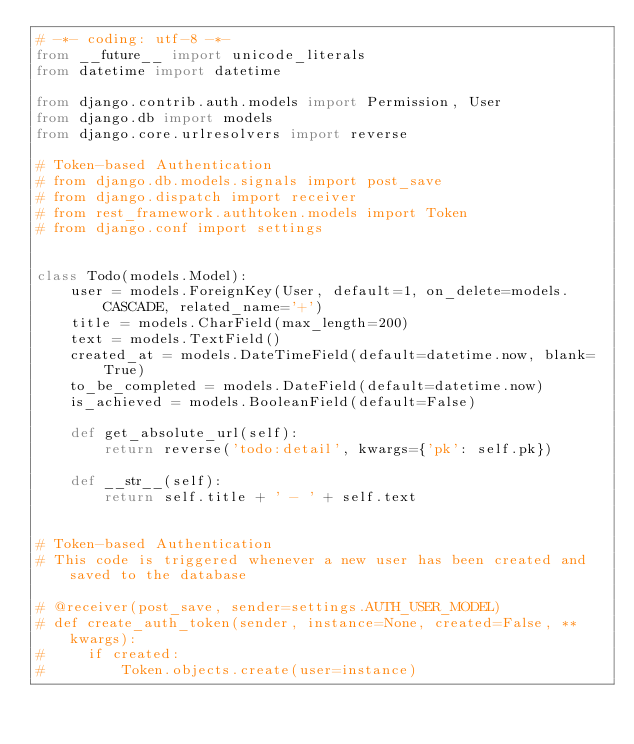<code> <loc_0><loc_0><loc_500><loc_500><_Python_># -*- coding: utf-8 -*-
from __future__ import unicode_literals
from datetime import datetime

from django.contrib.auth.models import Permission, User
from django.db import models
from django.core.urlresolvers import reverse

# Token-based Authentication
# from django.db.models.signals import post_save
# from django.dispatch import receiver
# from rest_framework.authtoken.models import Token
# from django.conf import settings


class Todo(models.Model):
    user = models.ForeignKey(User, default=1, on_delete=models.CASCADE, related_name='+')
    title = models.CharField(max_length=200)
    text = models.TextField()
    created_at = models.DateTimeField(default=datetime.now, blank=True)
    to_be_completed = models.DateField(default=datetime.now)
    is_achieved = models.BooleanField(default=False)

    def get_absolute_url(self):
        return reverse('todo:detail', kwargs={'pk': self.pk})

    def __str__(self):
        return self.title + ' - ' + self.text


# Token-based Authentication
# This code is triggered whenever a new user has been created and saved to the database

# @receiver(post_save, sender=settings.AUTH_USER_MODEL)
# def create_auth_token(sender, instance=None, created=False, **kwargs):
#     if created:
#         Token.objects.create(user=instance)
</code> 